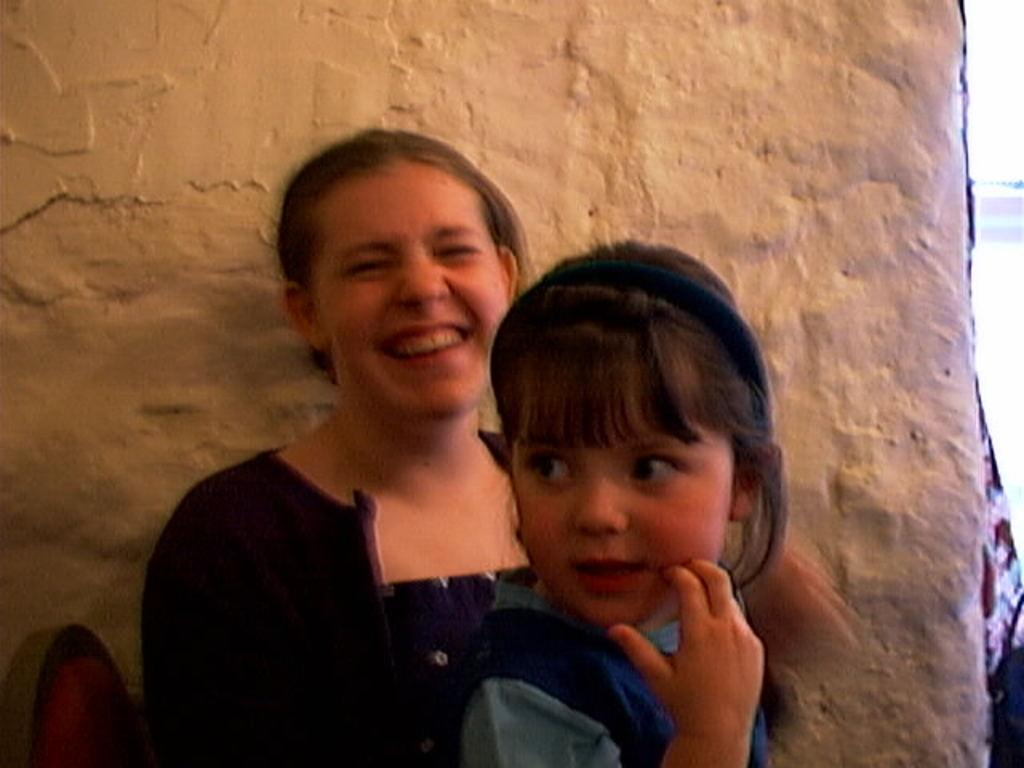How many people are in the image? There are two persons in the image. What are the persons doing in the image? The persons are sitting on chairs. What can be seen behind the persons in the image? There is a wall behind the persons. What type of scent can be detected in the image? There is no information about any scent in the image, so it cannot be determined. 